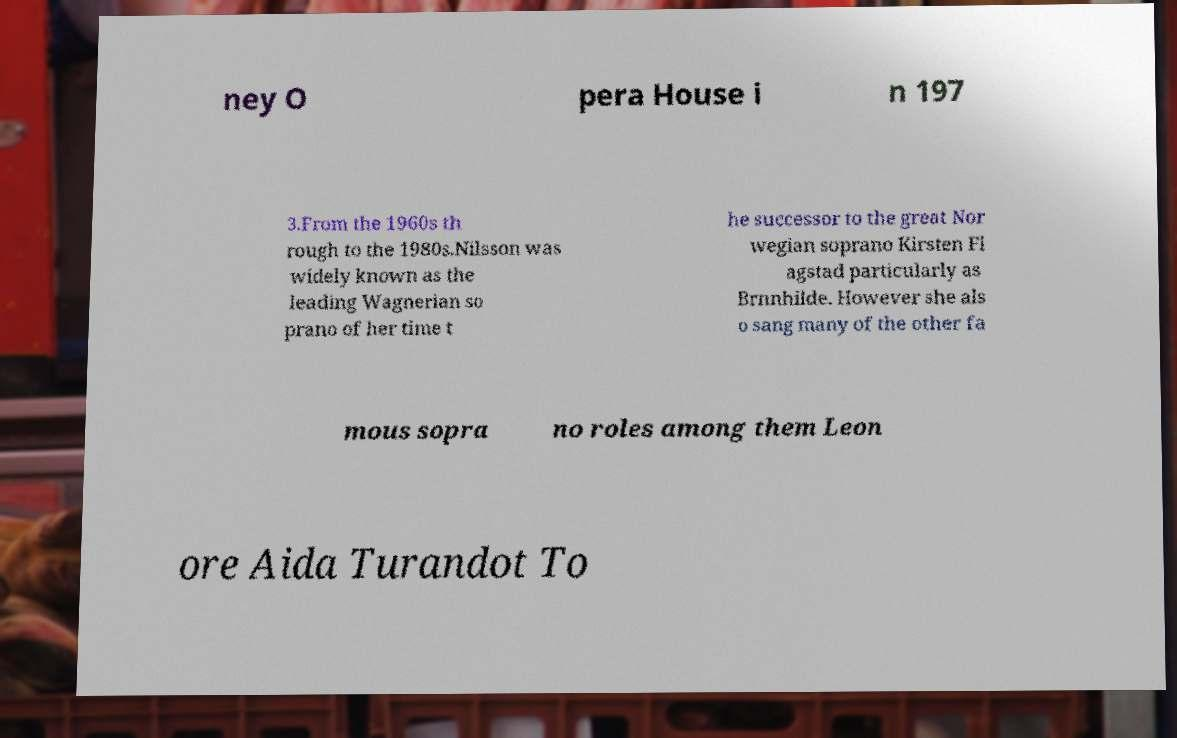For documentation purposes, I need the text within this image transcribed. Could you provide that? ney O pera House i n 197 3.From the 1960s th rough to the 1980s.Nilsson was widely known as the leading Wagnerian so prano of her time t he successor to the great Nor wegian soprano Kirsten Fl agstad particularly as Brnnhilde. However she als o sang many of the other fa mous sopra no roles among them Leon ore Aida Turandot To 